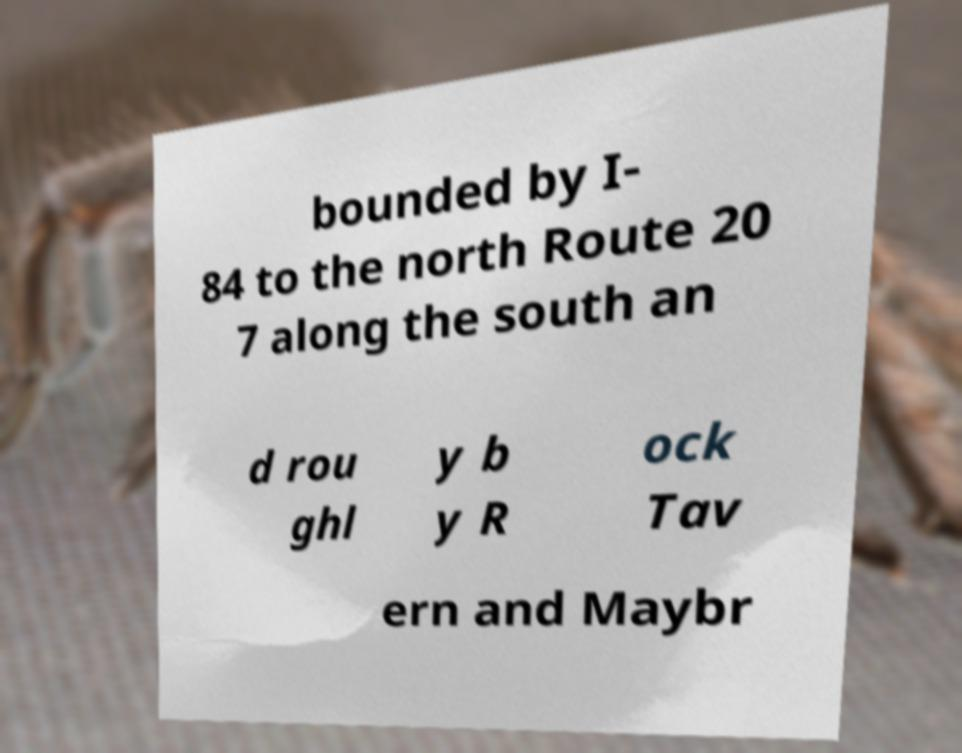What messages or text are displayed in this image? I need them in a readable, typed format. bounded by I- 84 to the north Route 20 7 along the south an d rou ghl y b y R ock Tav ern and Maybr 